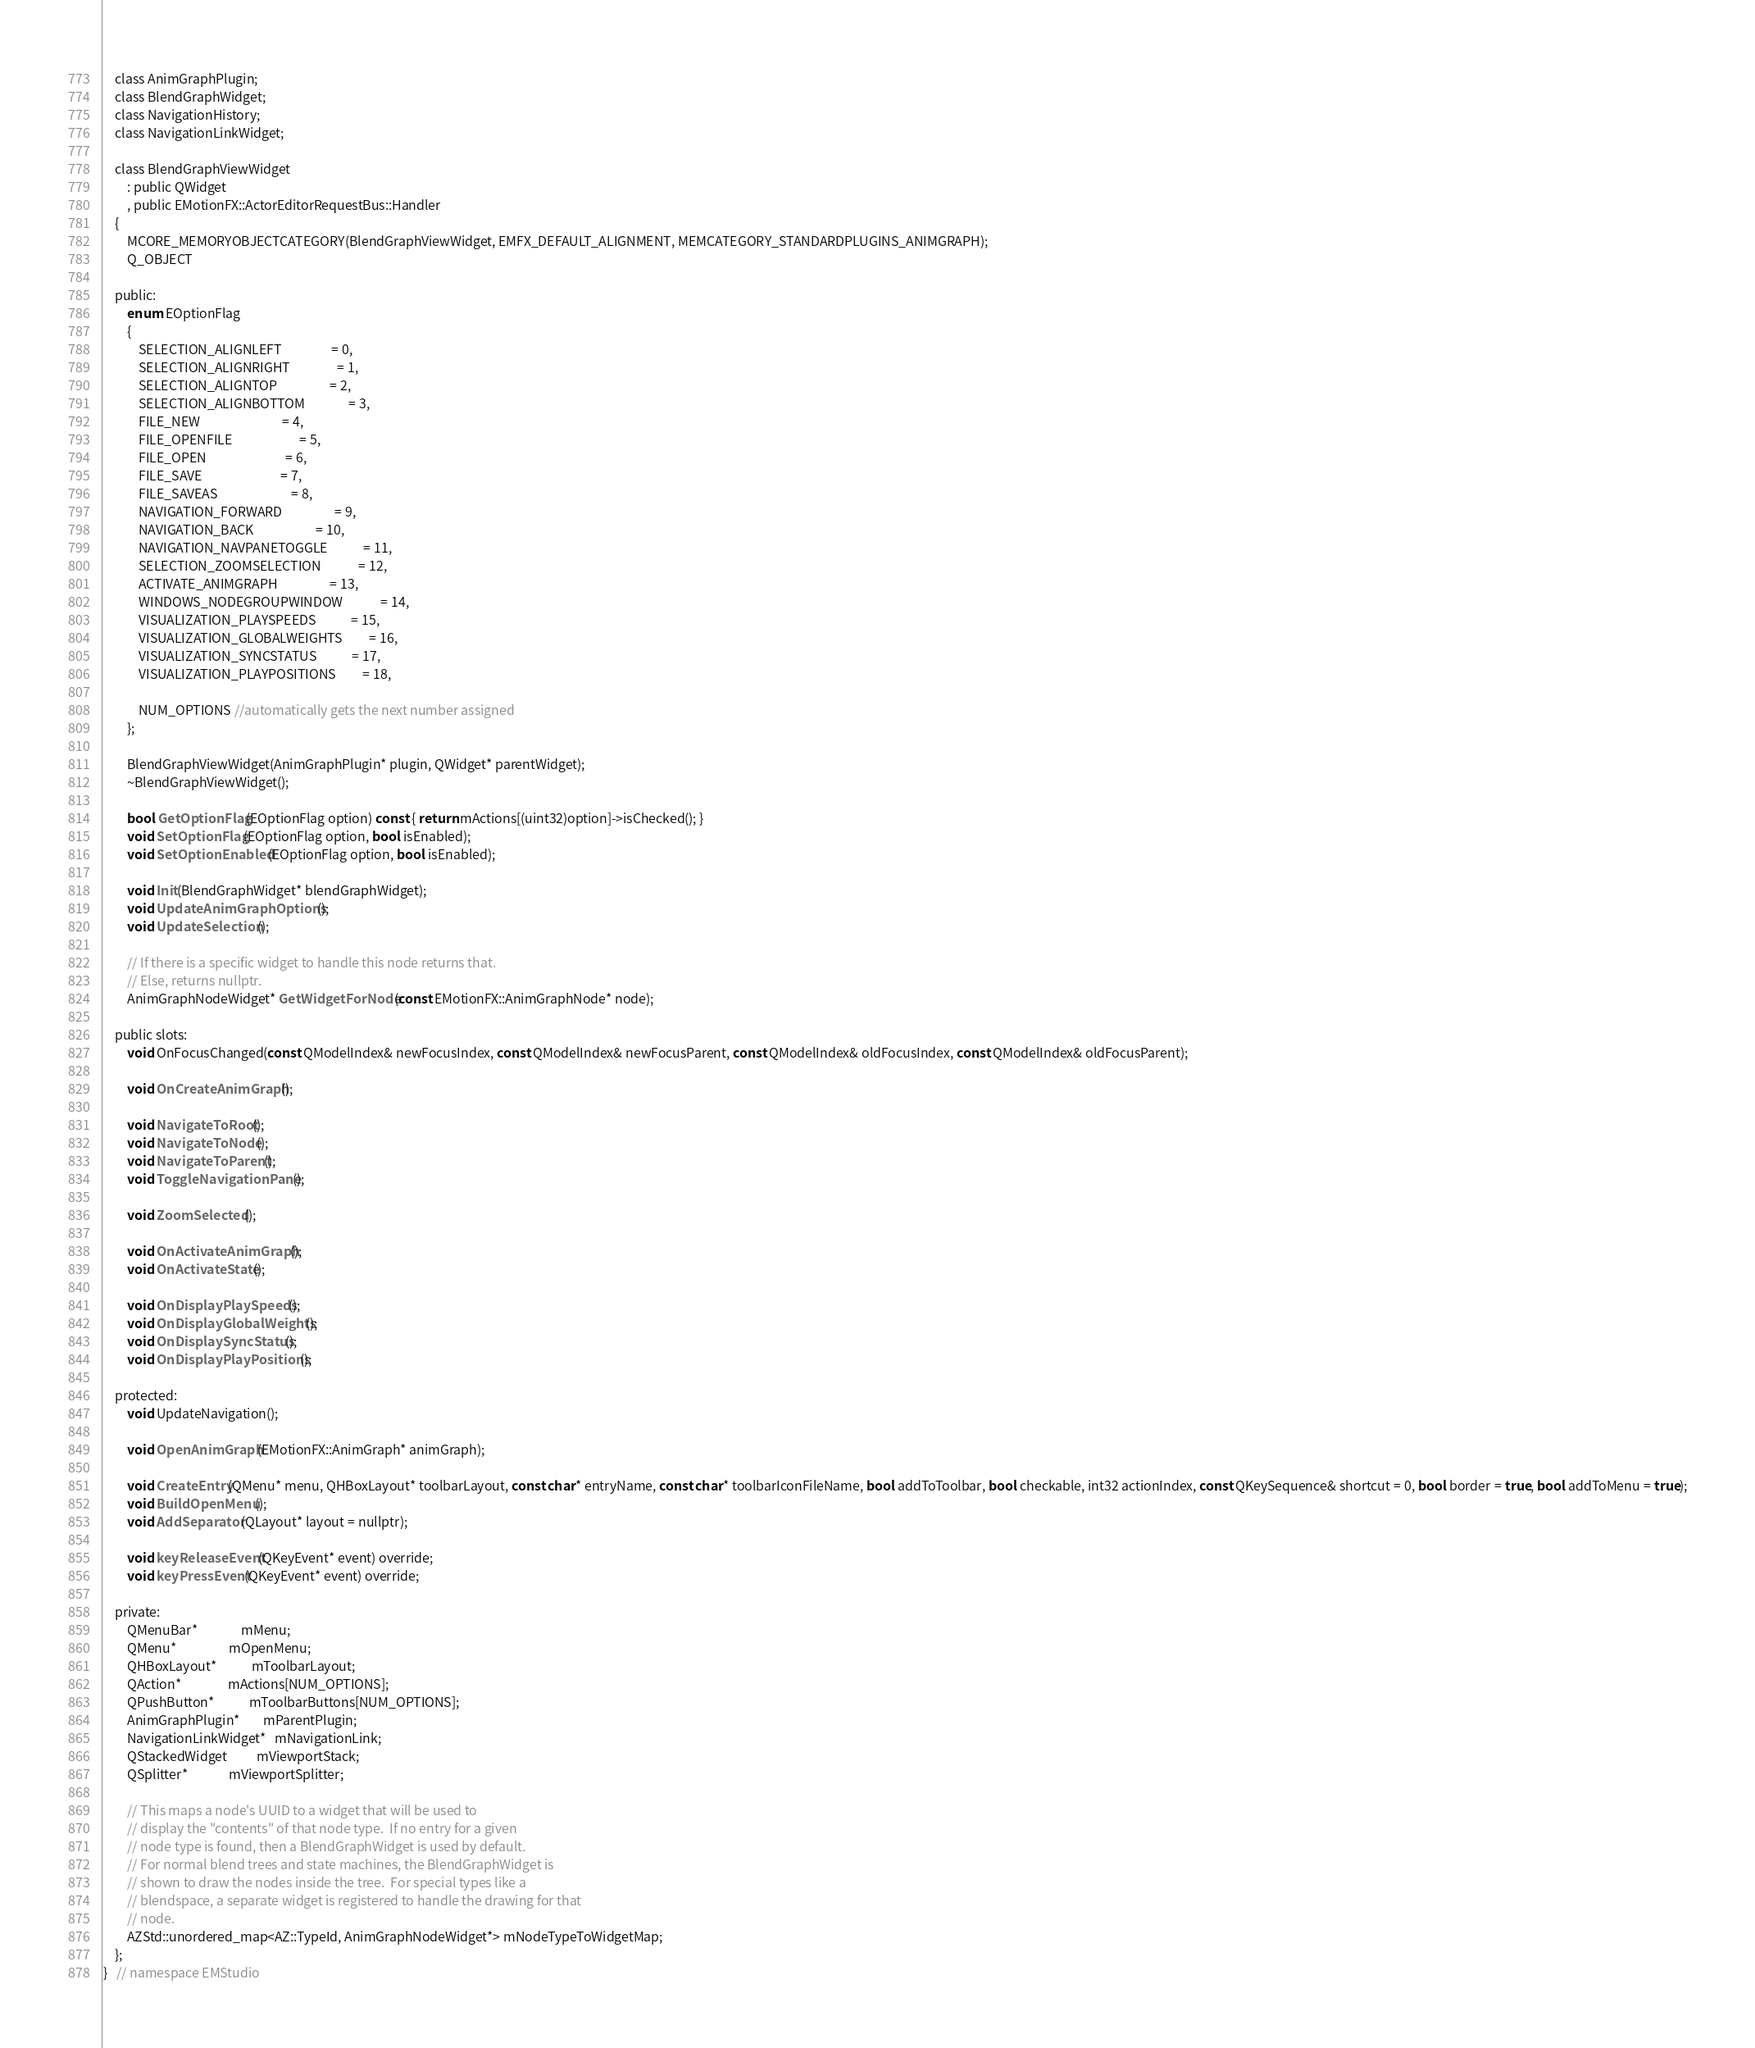<code> <loc_0><loc_0><loc_500><loc_500><_C_>    class AnimGraphPlugin;
    class BlendGraphWidget;
    class NavigationHistory;
    class NavigationLinkWidget;

    class BlendGraphViewWidget
        : public QWidget
        , public EMotionFX::ActorEditorRequestBus::Handler
    {
        MCORE_MEMORYOBJECTCATEGORY(BlendGraphViewWidget, EMFX_DEFAULT_ALIGNMENT, MEMCATEGORY_STANDARDPLUGINS_ANIMGRAPH);
        Q_OBJECT

    public:
        enum EOptionFlag
        {
            SELECTION_ALIGNLEFT                 = 0,
            SELECTION_ALIGNRIGHT                = 1,
            SELECTION_ALIGNTOP                  = 2,
            SELECTION_ALIGNBOTTOM               = 3,
            FILE_NEW                            = 4,
            FILE_OPENFILE                       = 5,
            FILE_OPEN                           = 6,
            FILE_SAVE                           = 7,
            FILE_SAVEAS                         = 8,
            NAVIGATION_FORWARD                  = 9,
            NAVIGATION_BACK                     = 10,
            NAVIGATION_NAVPANETOGGLE            = 11,
            SELECTION_ZOOMSELECTION             = 12,
            ACTIVATE_ANIMGRAPH                  = 13,
            WINDOWS_NODEGROUPWINDOW             = 14,
            VISUALIZATION_PLAYSPEEDS            = 15,
            VISUALIZATION_GLOBALWEIGHTS         = 16,
            VISUALIZATION_SYNCSTATUS            = 17,
            VISUALIZATION_PLAYPOSITIONS         = 18,

            NUM_OPTIONS //automatically gets the next number assigned
        };

        BlendGraphViewWidget(AnimGraphPlugin* plugin, QWidget* parentWidget);
        ~BlendGraphViewWidget();

        bool GetOptionFlag(EOptionFlag option) const { return mActions[(uint32)option]->isChecked(); }
        void SetOptionFlag(EOptionFlag option, bool isEnabled);
        void SetOptionEnabled(EOptionFlag option, bool isEnabled);

        void Init(BlendGraphWidget* blendGraphWidget);
        void UpdateAnimGraphOptions();
        void UpdateSelection();

        // If there is a specific widget to handle this node returns that.
        // Else, returns nullptr.
        AnimGraphNodeWidget* GetWidgetForNode(const EMotionFX::AnimGraphNode* node);

    public slots:
        void OnFocusChanged(const QModelIndex& newFocusIndex, const QModelIndex& newFocusParent, const QModelIndex& oldFocusIndex, const QModelIndex& oldFocusParent);

        void OnCreateAnimGraph();

        void NavigateToRoot();
        void NavigateToNode();
        void NavigateToParent();
        void ToggleNavigationPane();

        void ZoomSelected();

        void OnActivateAnimGraph();
        void OnActivateState();

        void OnDisplayPlaySpeeds();
        void OnDisplayGlobalWeights();
        void OnDisplaySyncStatus();
        void OnDisplayPlayPositions();

    protected:
        void UpdateNavigation();

        void OpenAnimGraph(EMotionFX::AnimGraph* animGraph);

        void CreateEntry(QMenu* menu, QHBoxLayout* toolbarLayout, const char* entryName, const char* toolbarIconFileName, bool addToToolbar, bool checkable, int32 actionIndex, const QKeySequence& shortcut = 0, bool border = true, bool addToMenu = true);
        void BuildOpenMenu();
        void AddSeparator(QLayout* layout = nullptr);

        void keyReleaseEvent(QKeyEvent* event) override;
        void keyPressEvent(QKeyEvent* event) override;

    private:
        QMenuBar*               mMenu;
        QMenu*                  mOpenMenu;
        QHBoxLayout*            mToolbarLayout;
        QAction*                mActions[NUM_OPTIONS];
        QPushButton*            mToolbarButtons[NUM_OPTIONS];
        AnimGraphPlugin*        mParentPlugin;
        NavigationLinkWidget*   mNavigationLink;
        QStackedWidget          mViewportStack;
        QSplitter*              mViewportSplitter;

        // This maps a node's UUID to a widget that will be used to
        // display the "contents" of that node type.  If no entry for a given
        // node type is found, then a BlendGraphWidget is used by default.
        // For normal blend trees and state machines, the BlendGraphWidget is
        // shown to draw the nodes inside the tree.  For special types like a
        // blendspace, a separate widget is registered to handle the drawing for that
        // node.
        AZStd::unordered_map<AZ::TypeId, AnimGraphNodeWidget*> mNodeTypeToWidgetMap;
    };
}   // namespace EMStudio
</code> 